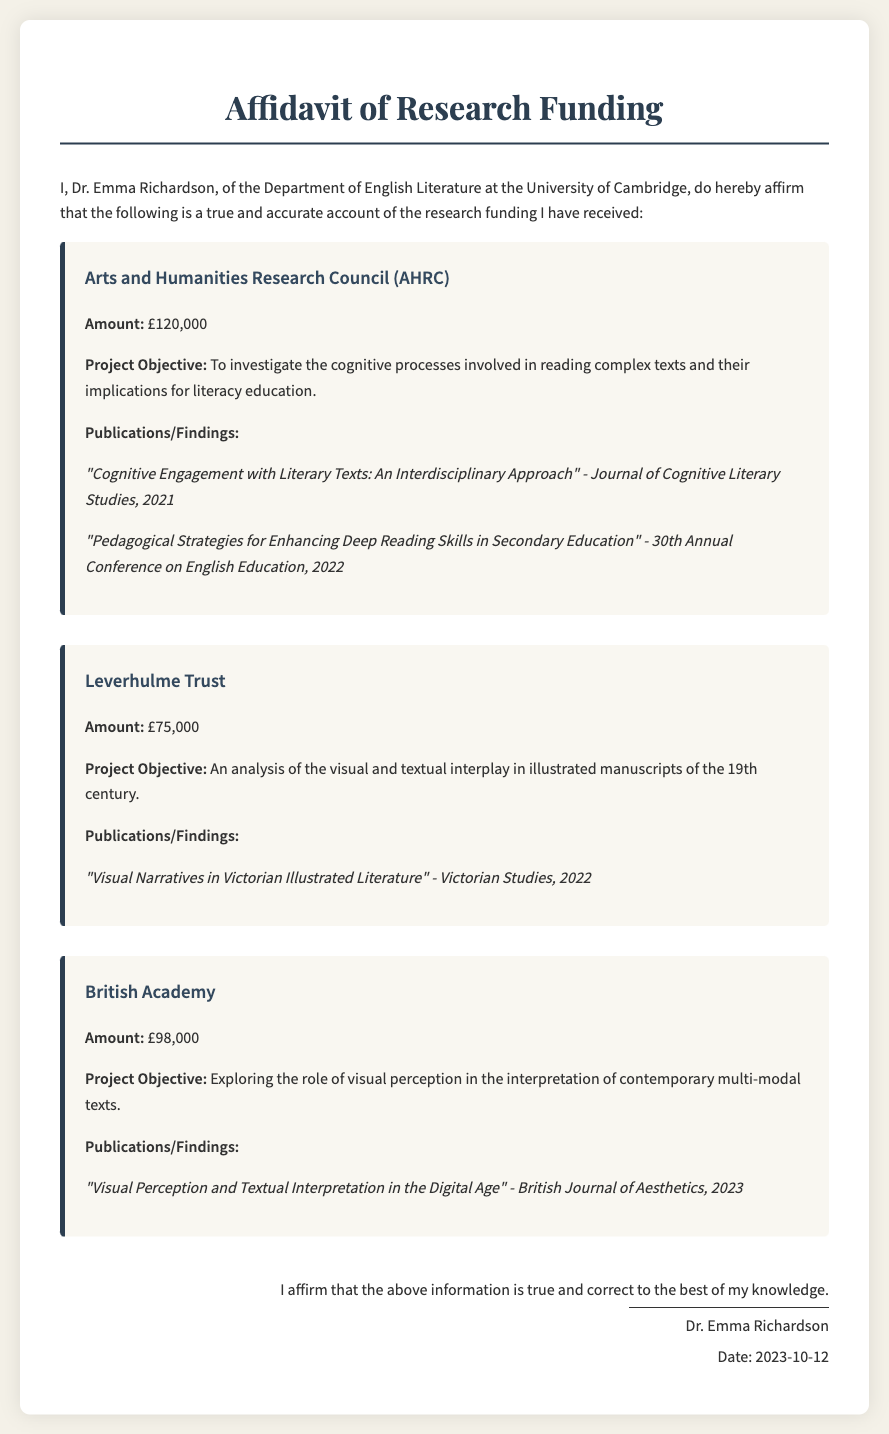What is the total amount of funding received? The total amount of funding is the sum of all individual grants listed: £120,000 + £75,000 + £98,000 = £293,000.
Answer: £293,000 Who is the signatory of the affidavit? The affidavit is signed by Dr. Emma Richardson, as indicated in the signature section at the bottom of the document.
Answer: Dr. Emma Richardson What is the project objective for the AHRC funding? The AHRC funding project objective is provided in its section: "To investigate the cognitive processes involved in reading complex texts and their implications for literacy education."
Answer: To investigate the cognitive processes involved in reading complex texts and their implications for literacy education How much funding did the Leverhulme Trust provide? The amount of funding from the Leverhulme Trust is explicitly listed in its section of the document.
Answer: £75,000 Which journal published the findings related to visual narratives in 2022? The publication associated with visual narratives, mentioned under the Leverhulme Trust funding, is clarified in the publications list.
Answer: Victorian Studies What is the purpose of the British Academy funded project? The objective of the British Academy project can be found in its respective section of the affidavit, indicating its goal.
Answer: Exploring the role of visual perception in the interpretation of contemporary multi-modal texts When was the affidavit signed? The date of signature is provided in the signature section at the end of the document.
Answer: 2023-10-12 What type of research did the AHRC funding support? The type of research related to the AHRC funding is defined by its project objective, indicating the focus area.
Answer: Cognitive processes in reading complex texts 